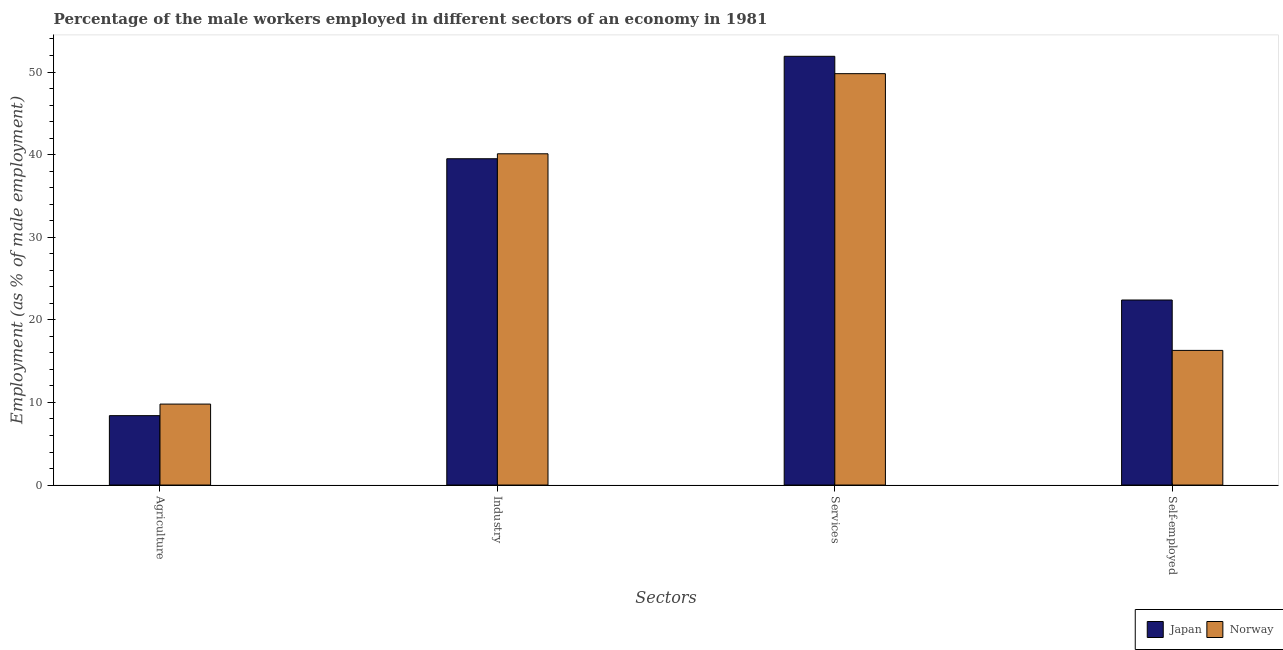How many different coloured bars are there?
Offer a very short reply. 2. How many bars are there on the 2nd tick from the left?
Provide a short and direct response. 2. How many bars are there on the 2nd tick from the right?
Give a very brief answer. 2. What is the label of the 1st group of bars from the left?
Offer a very short reply. Agriculture. What is the percentage of self employed male workers in Japan?
Your answer should be compact. 22.4. Across all countries, what is the maximum percentage of male workers in industry?
Your answer should be very brief. 40.1. Across all countries, what is the minimum percentage of self employed male workers?
Offer a very short reply. 16.3. What is the total percentage of male workers in industry in the graph?
Offer a terse response. 79.6. What is the difference between the percentage of male workers in industry in Japan and that in Norway?
Your response must be concise. -0.6. What is the difference between the percentage of male workers in industry in Japan and the percentage of male workers in agriculture in Norway?
Your response must be concise. 29.7. What is the average percentage of male workers in industry per country?
Keep it short and to the point. 39.8. What is the difference between the percentage of self employed male workers and percentage of male workers in industry in Norway?
Offer a terse response. -23.8. In how many countries, is the percentage of self employed male workers greater than 32 %?
Keep it short and to the point. 0. What is the ratio of the percentage of male workers in services in Norway to that in Japan?
Make the answer very short. 0.96. What is the difference between the highest and the second highest percentage of male workers in agriculture?
Provide a short and direct response. 1.4. What is the difference between the highest and the lowest percentage of male workers in industry?
Make the answer very short. 0.6. What does the 1st bar from the right in Self-employed represents?
Offer a terse response. Norway. Is it the case that in every country, the sum of the percentage of male workers in agriculture and percentage of male workers in industry is greater than the percentage of male workers in services?
Offer a terse response. No. How many bars are there?
Keep it short and to the point. 8. Are all the bars in the graph horizontal?
Keep it short and to the point. No. What is the difference between two consecutive major ticks on the Y-axis?
Offer a terse response. 10. Where does the legend appear in the graph?
Provide a succinct answer. Bottom right. How many legend labels are there?
Offer a very short reply. 2. What is the title of the graph?
Keep it short and to the point. Percentage of the male workers employed in different sectors of an economy in 1981. What is the label or title of the X-axis?
Give a very brief answer. Sectors. What is the label or title of the Y-axis?
Your answer should be compact. Employment (as % of male employment). What is the Employment (as % of male employment) in Japan in Agriculture?
Provide a succinct answer. 8.4. What is the Employment (as % of male employment) of Norway in Agriculture?
Offer a terse response. 9.8. What is the Employment (as % of male employment) of Japan in Industry?
Provide a short and direct response. 39.5. What is the Employment (as % of male employment) in Norway in Industry?
Provide a short and direct response. 40.1. What is the Employment (as % of male employment) in Japan in Services?
Offer a terse response. 51.9. What is the Employment (as % of male employment) in Norway in Services?
Provide a short and direct response. 49.8. What is the Employment (as % of male employment) in Japan in Self-employed?
Your response must be concise. 22.4. What is the Employment (as % of male employment) of Norway in Self-employed?
Your answer should be compact. 16.3. Across all Sectors, what is the maximum Employment (as % of male employment) in Japan?
Keep it short and to the point. 51.9. Across all Sectors, what is the maximum Employment (as % of male employment) of Norway?
Your answer should be compact. 49.8. Across all Sectors, what is the minimum Employment (as % of male employment) in Japan?
Ensure brevity in your answer.  8.4. Across all Sectors, what is the minimum Employment (as % of male employment) in Norway?
Provide a short and direct response. 9.8. What is the total Employment (as % of male employment) of Japan in the graph?
Your answer should be compact. 122.2. What is the total Employment (as % of male employment) of Norway in the graph?
Provide a succinct answer. 116. What is the difference between the Employment (as % of male employment) in Japan in Agriculture and that in Industry?
Your response must be concise. -31.1. What is the difference between the Employment (as % of male employment) in Norway in Agriculture and that in Industry?
Offer a terse response. -30.3. What is the difference between the Employment (as % of male employment) in Japan in Agriculture and that in Services?
Your response must be concise. -43.5. What is the difference between the Employment (as % of male employment) of Norway in Agriculture and that in Services?
Provide a succinct answer. -40. What is the difference between the Employment (as % of male employment) of Norway in Agriculture and that in Self-employed?
Offer a very short reply. -6.5. What is the difference between the Employment (as % of male employment) in Norway in Industry and that in Services?
Offer a terse response. -9.7. What is the difference between the Employment (as % of male employment) in Norway in Industry and that in Self-employed?
Your answer should be compact. 23.8. What is the difference between the Employment (as % of male employment) of Japan in Services and that in Self-employed?
Provide a short and direct response. 29.5. What is the difference between the Employment (as % of male employment) of Norway in Services and that in Self-employed?
Provide a succinct answer. 33.5. What is the difference between the Employment (as % of male employment) in Japan in Agriculture and the Employment (as % of male employment) in Norway in Industry?
Give a very brief answer. -31.7. What is the difference between the Employment (as % of male employment) of Japan in Agriculture and the Employment (as % of male employment) of Norway in Services?
Make the answer very short. -41.4. What is the difference between the Employment (as % of male employment) in Japan in Agriculture and the Employment (as % of male employment) in Norway in Self-employed?
Offer a terse response. -7.9. What is the difference between the Employment (as % of male employment) of Japan in Industry and the Employment (as % of male employment) of Norway in Self-employed?
Keep it short and to the point. 23.2. What is the difference between the Employment (as % of male employment) of Japan in Services and the Employment (as % of male employment) of Norway in Self-employed?
Ensure brevity in your answer.  35.6. What is the average Employment (as % of male employment) in Japan per Sectors?
Make the answer very short. 30.55. What is the average Employment (as % of male employment) in Norway per Sectors?
Your answer should be compact. 29. What is the difference between the Employment (as % of male employment) of Japan and Employment (as % of male employment) of Norway in Agriculture?
Offer a very short reply. -1.4. What is the difference between the Employment (as % of male employment) in Japan and Employment (as % of male employment) in Norway in Services?
Keep it short and to the point. 2.1. What is the ratio of the Employment (as % of male employment) in Japan in Agriculture to that in Industry?
Give a very brief answer. 0.21. What is the ratio of the Employment (as % of male employment) in Norway in Agriculture to that in Industry?
Your answer should be very brief. 0.24. What is the ratio of the Employment (as % of male employment) in Japan in Agriculture to that in Services?
Your answer should be compact. 0.16. What is the ratio of the Employment (as % of male employment) in Norway in Agriculture to that in Services?
Provide a short and direct response. 0.2. What is the ratio of the Employment (as % of male employment) of Norway in Agriculture to that in Self-employed?
Offer a terse response. 0.6. What is the ratio of the Employment (as % of male employment) in Japan in Industry to that in Services?
Provide a short and direct response. 0.76. What is the ratio of the Employment (as % of male employment) of Norway in Industry to that in Services?
Keep it short and to the point. 0.81. What is the ratio of the Employment (as % of male employment) of Japan in Industry to that in Self-employed?
Offer a very short reply. 1.76. What is the ratio of the Employment (as % of male employment) of Norway in Industry to that in Self-employed?
Offer a very short reply. 2.46. What is the ratio of the Employment (as % of male employment) in Japan in Services to that in Self-employed?
Provide a succinct answer. 2.32. What is the ratio of the Employment (as % of male employment) in Norway in Services to that in Self-employed?
Offer a terse response. 3.06. What is the difference between the highest and the second highest Employment (as % of male employment) of Norway?
Your response must be concise. 9.7. What is the difference between the highest and the lowest Employment (as % of male employment) of Japan?
Give a very brief answer. 43.5. 